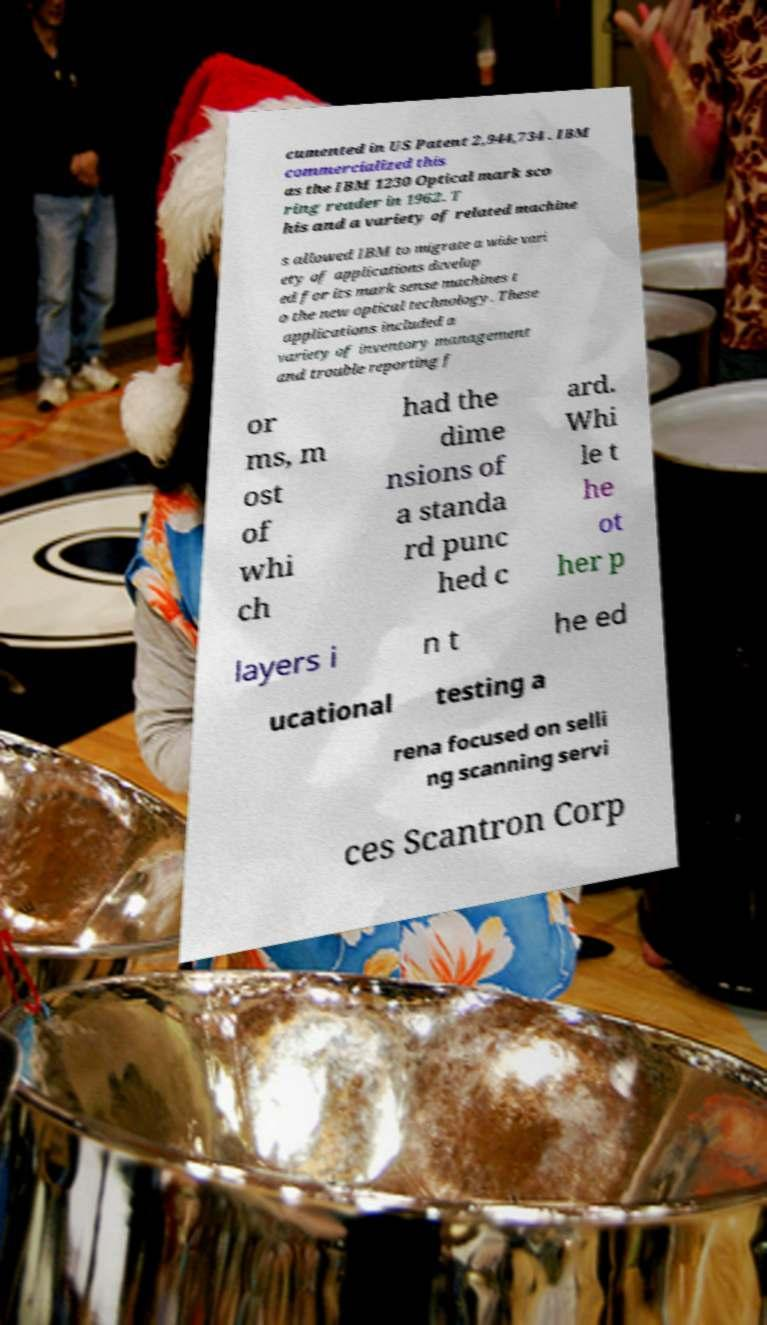What messages or text are displayed in this image? I need them in a readable, typed format. cumented in US Patent 2,944,734 . IBM commercialized this as the IBM 1230 Optical mark sco ring reader in 1962. T his and a variety of related machine s allowed IBM to migrate a wide vari ety of applications develop ed for its mark sense machines t o the new optical technology. These applications included a variety of inventory management and trouble reporting f or ms, m ost of whi ch had the dime nsions of a standa rd punc hed c ard. Whi le t he ot her p layers i n t he ed ucational testing a rena focused on selli ng scanning servi ces Scantron Corp 